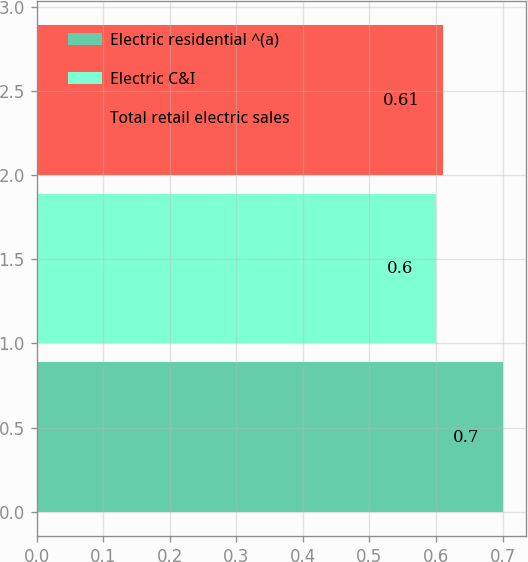Convert chart. <chart><loc_0><loc_0><loc_500><loc_500><bar_chart><fcel>Electric residential ^(a)<fcel>Electric C&I<fcel>Total retail electric sales<nl><fcel>0.7<fcel>0.6<fcel>0.61<nl></chart> 